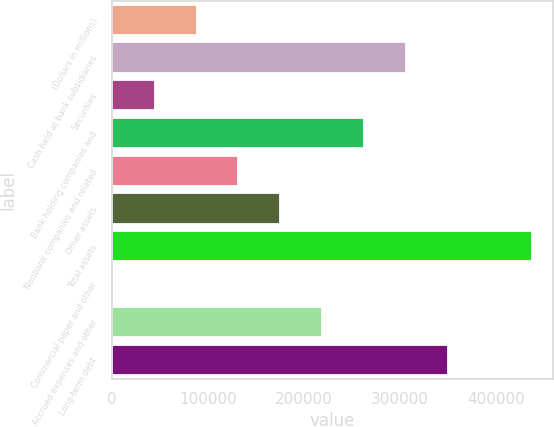<chart> <loc_0><loc_0><loc_500><loc_500><bar_chart><fcel>(Dollars in millions)<fcel>Cash held at bank subsidiaries<fcel>Securities<fcel>Bank holding companies and<fcel>Nonbank companies and related<fcel>Other assets<fcel>Total assets<fcel>Commercial paper and other<fcel>Accrued expenses and other<fcel>Long-term debt<nl><fcel>87877<fcel>306567<fcel>44139<fcel>262829<fcel>131615<fcel>175353<fcel>437781<fcel>401<fcel>219091<fcel>350305<nl></chart> 